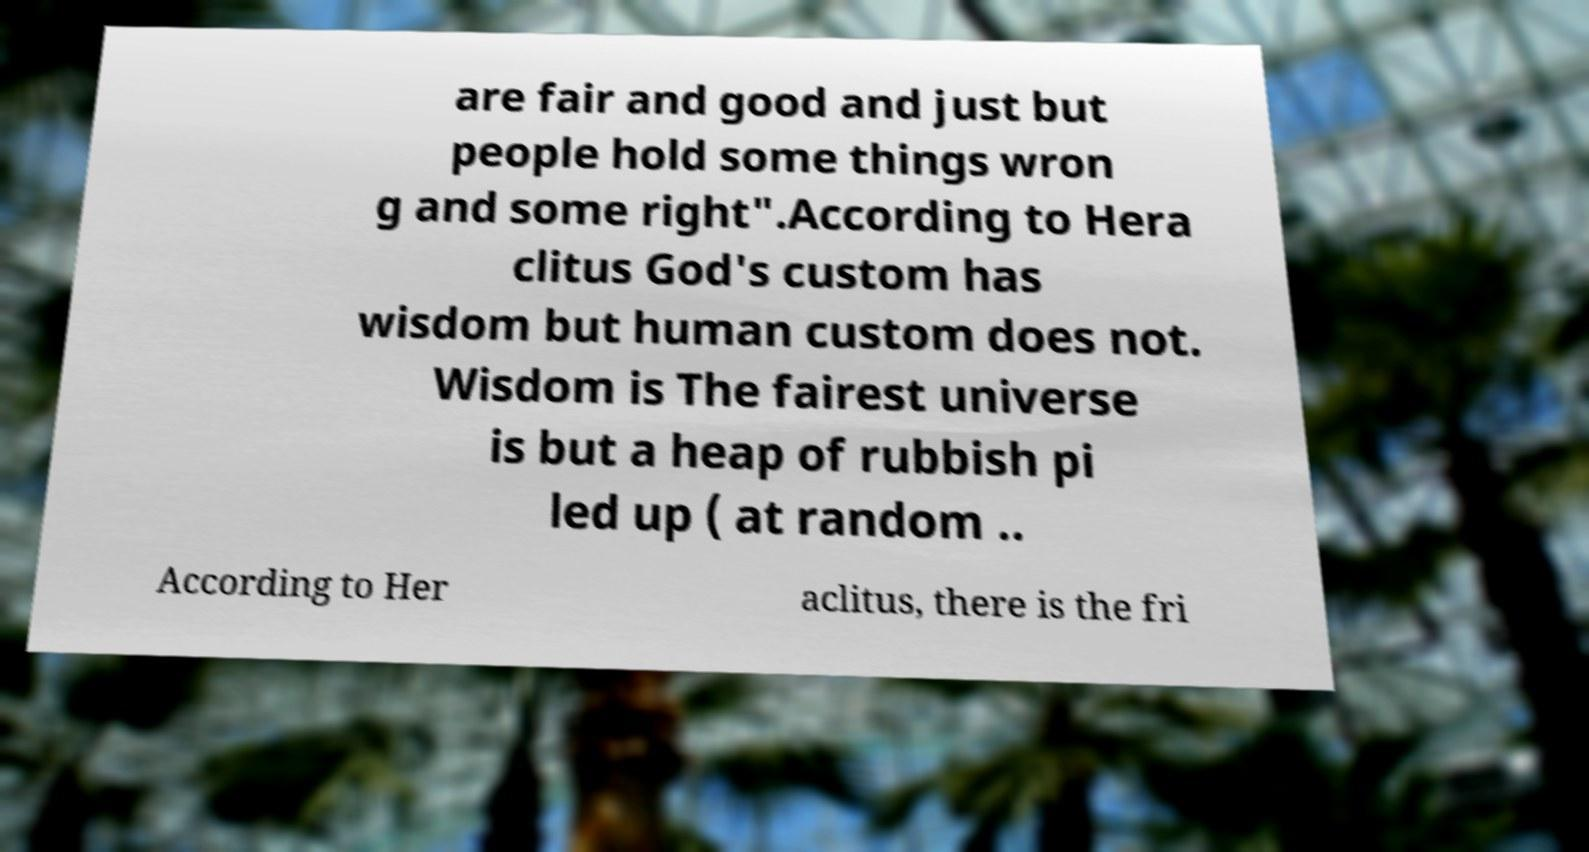There's text embedded in this image that I need extracted. Can you transcribe it verbatim? are fair and good and just but people hold some things wron g and some right".According to Hera clitus God's custom has wisdom but human custom does not. Wisdom is The fairest universe is but a heap of rubbish pi led up ( at random .. According to Her aclitus, there is the fri 